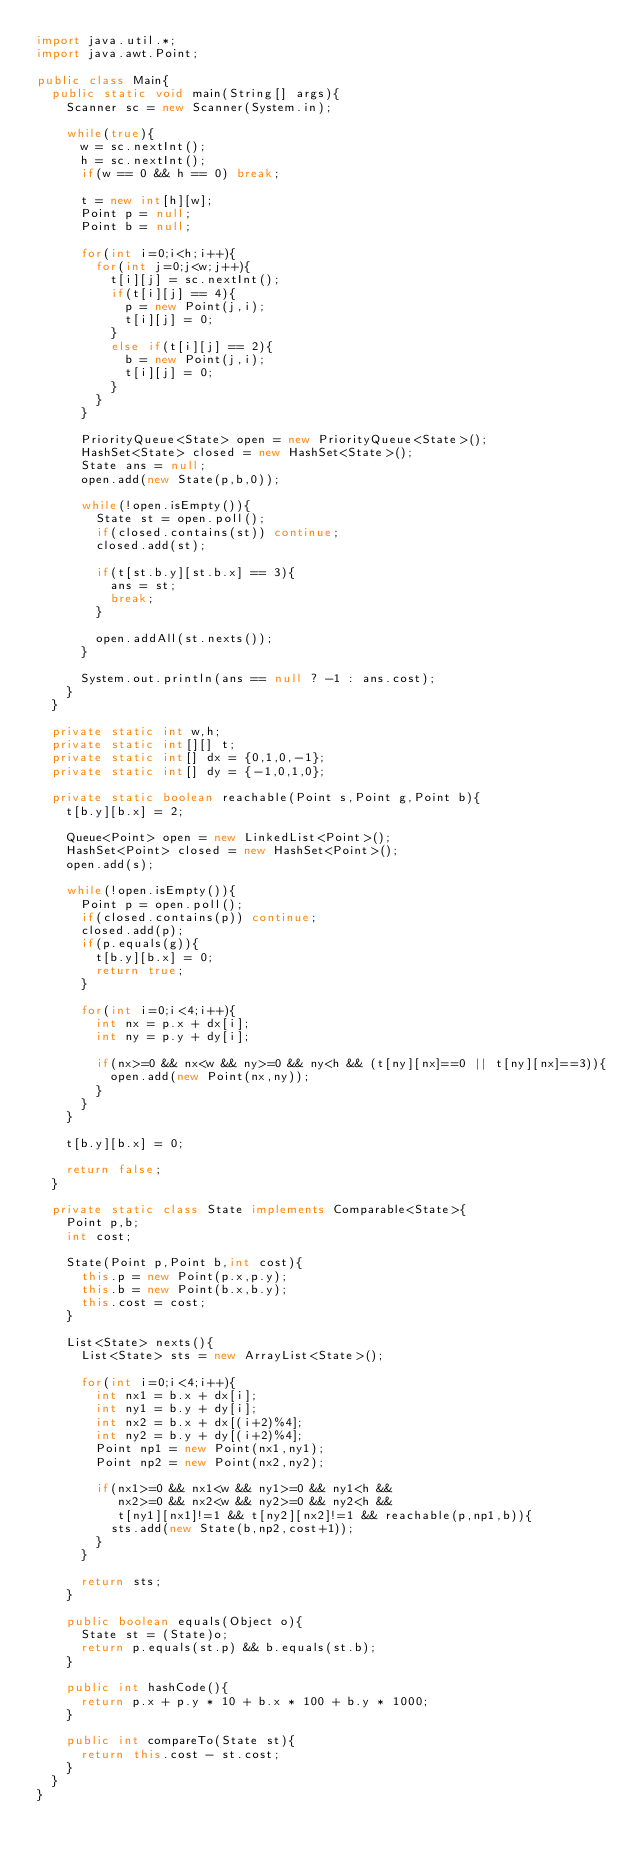<code> <loc_0><loc_0><loc_500><loc_500><_Java_>import java.util.*;
import java.awt.Point;

public class Main{
	public static void main(String[] args){
		Scanner sc = new Scanner(System.in);

		while(true){
			w = sc.nextInt();
			h = sc.nextInt();
			if(w == 0 && h == 0) break;

			t = new int[h][w];
			Point p = null;
			Point b = null;

			for(int i=0;i<h;i++){
				for(int j=0;j<w;j++){
					t[i][j] = sc.nextInt();
					if(t[i][j] == 4){
						p = new Point(j,i);
						t[i][j] = 0;
					}
					else if(t[i][j] == 2){
						b = new Point(j,i);
						t[i][j] = 0;
					}
				}
			}

			PriorityQueue<State> open = new PriorityQueue<State>();
			HashSet<State> closed = new HashSet<State>();
			State ans = null;
			open.add(new State(p,b,0));

			while(!open.isEmpty()){
				State st = open.poll();
				if(closed.contains(st)) continue;
				closed.add(st);

				if(t[st.b.y][st.b.x] == 3){
					ans = st;
					break;
				}

				open.addAll(st.nexts());
			}

			System.out.println(ans == null ? -1 : ans.cost);
		}
	}

	private static int w,h;
	private static int[][] t;
	private static int[] dx = {0,1,0,-1};
	private static int[] dy = {-1,0,1,0};

	private static boolean reachable(Point s,Point g,Point b){
		t[b.y][b.x] = 2;

		Queue<Point> open = new LinkedList<Point>();
		HashSet<Point> closed = new HashSet<Point>();
		open.add(s);

		while(!open.isEmpty()){
			Point p = open.poll();
			if(closed.contains(p)) continue;
			closed.add(p);
			if(p.equals(g)){
				t[b.y][b.x] = 0;
				return true;
			}

			for(int i=0;i<4;i++){
				int nx = p.x + dx[i];
				int ny = p.y + dy[i];

				if(nx>=0 && nx<w && ny>=0 && ny<h && (t[ny][nx]==0 || t[ny][nx]==3)){
					open.add(new Point(nx,ny));
				}
			}
		}

		t[b.y][b.x] = 0;

		return false;
	}

	private static class State implements Comparable<State>{
		Point p,b;
		int cost;

		State(Point p,Point b,int cost){
			this.p = new Point(p.x,p.y);
			this.b = new Point(b.x,b.y);
			this.cost = cost;
		}

		List<State> nexts(){
			List<State> sts = new ArrayList<State>();

			for(int i=0;i<4;i++){
				int nx1 = b.x + dx[i];
				int ny1 = b.y + dy[i];
				int nx2 = b.x + dx[(i+2)%4];
				int ny2 = b.y + dy[(i+2)%4];
				Point np1 = new Point(nx1,ny1);
				Point np2 = new Point(nx2,ny2);

				if(nx1>=0 && nx1<w && ny1>=0 && ny1<h &&
					 nx2>=0 && nx2<w && ny2>=0 && ny2<h &&
					 t[ny1][nx1]!=1 && t[ny2][nx2]!=1 && reachable(p,np1,b)){
					sts.add(new State(b,np2,cost+1));
				}
			}

			return sts;
		}

		public boolean equals(Object o){
			State st = (State)o;
			return p.equals(st.p) && b.equals(st.b);
		}

		public int hashCode(){
			return p.x + p.y * 10 + b.x * 100 + b.y * 1000;
		}

		public int compareTo(State st){
			return this.cost - st.cost;
		}
	}
}</code> 